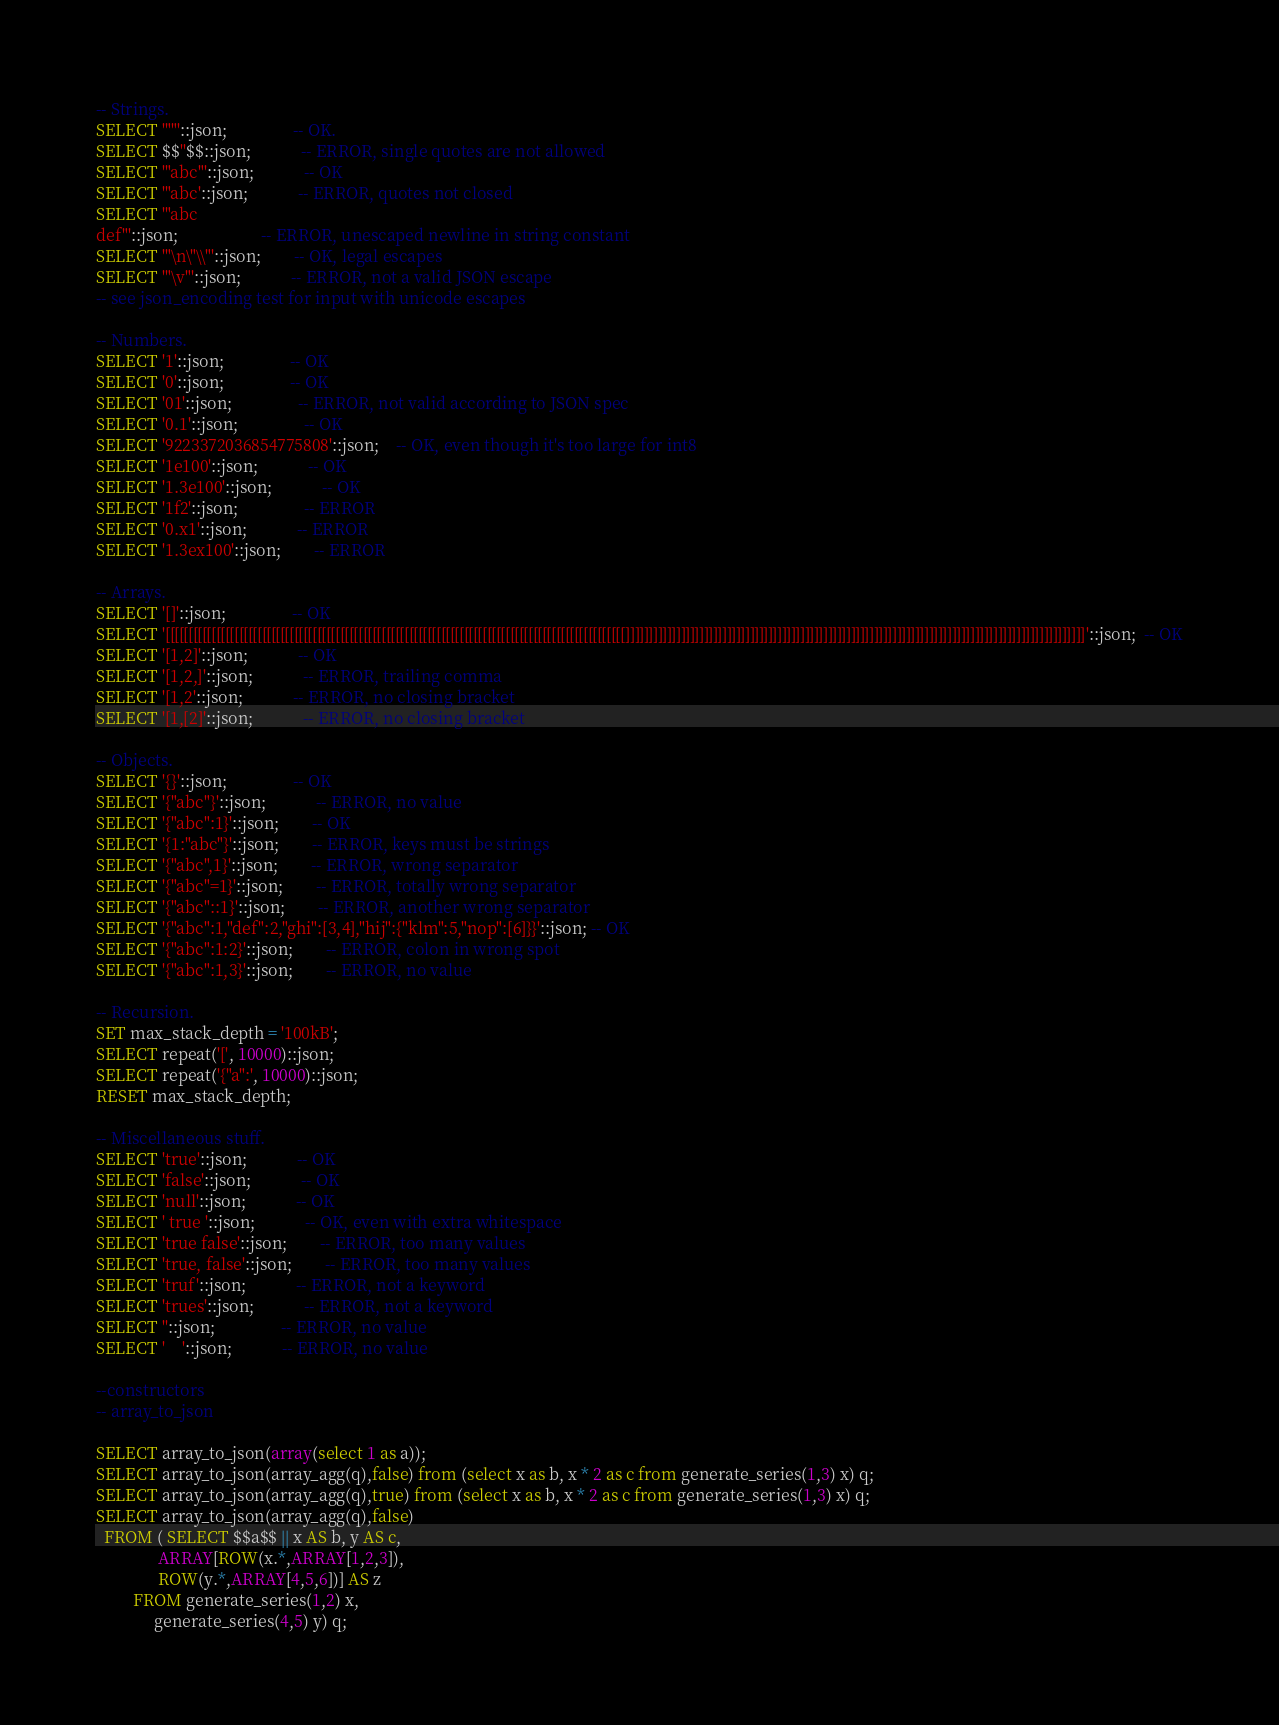Convert code to text. <code><loc_0><loc_0><loc_500><loc_500><_SQL_>-- Strings.
SELECT '""'::json;				-- OK.
SELECT $$''$$::json;			-- ERROR, single quotes are not allowed
SELECT '"abc"'::json;			-- OK
SELECT '"abc'::json;			-- ERROR, quotes not closed
SELECT '"abc
def"'::json;					-- ERROR, unescaped newline in string constant
SELECT '"\n\"\\"'::json;		-- OK, legal escapes
SELECT '"\v"'::json;			-- ERROR, not a valid JSON escape
-- see json_encoding test for input with unicode escapes

-- Numbers.
SELECT '1'::json;				-- OK
SELECT '0'::json;				-- OK
SELECT '01'::json;				-- ERROR, not valid according to JSON spec
SELECT '0.1'::json;				-- OK
SELECT '9223372036854775808'::json;	-- OK, even though it's too large for int8
SELECT '1e100'::json;			-- OK
SELECT '1.3e100'::json;			-- OK
SELECT '1f2'::json;				-- ERROR
SELECT '0.x1'::json;			-- ERROR
SELECT '1.3ex100'::json;		-- ERROR

-- Arrays.
SELECT '[]'::json;				-- OK
SELECT '[[[[[[[[[[[[[[[[[[[[[[[[[[[[[[[[[[[[[[[[[[[[[[[[[[[[[[[[[[[[[[[[[[[[[[[[[[[[[[[[[[[[[[[[[[[[[[[[[[[[]]]]]]]]]]]]]]]]]]]]]]]]]]]]]]]]]]]]]]]]]]]]]]]]]]]]]]]]]]]]]]]]]]]]]]]]]]]]]]]]]]]]]]]]]]]]]]]]]]]]'::json;  -- OK
SELECT '[1,2]'::json;			-- OK
SELECT '[1,2,]'::json;			-- ERROR, trailing comma
SELECT '[1,2'::json;			-- ERROR, no closing bracket
SELECT '[1,[2]'::json;			-- ERROR, no closing bracket

-- Objects.
SELECT '{}'::json;				-- OK
SELECT '{"abc"}'::json;			-- ERROR, no value
SELECT '{"abc":1}'::json;		-- OK
SELECT '{1:"abc"}'::json;		-- ERROR, keys must be strings
SELECT '{"abc",1}'::json;		-- ERROR, wrong separator
SELECT '{"abc"=1}'::json;		-- ERROR, totally wrong separator
SELECT '{"abc"::1}'::json;		-- ERROR, another wrong separator
SELECT '{"abc":1,"def":2,"ghi":[3,4],"hij":{"klm":5,"nop":[6]}}'::json; -- OK
SELECT '{"abc":1:2}'::json;		-- ERROR, colon in wrong spot
SELECT '{"abc":1,3}'::json;		-- ERROR, no value

-- Recursion.
SET max_stack_depth = '100kB';
SELECT repeat('[', 10000)::json;
SELECT repeat('{"a":', 10000)::json;
RESET max_stack_depth;

-- Miscellaneous stuff.
SELECT 'true'::json;			-- OK
SELECT 'false'::json;			-- OK
SELECT 'null'::json;			-- OK
SELECT ' true '::json;			-- OK, even with extra whitespace
SELECT 'true false'::json;		-- ERROR, too many values
SELECT 'true, false'::json;		-- ERROR, too many values
SELECT 'truf'::json;			-- ERROR, not a keyword
SELECT 'trues'::json;			-- ERROR, not a keyword
SELECT ''::json;				-- ERROR, no value
SELECT '    '::json;			-- ERROR, no value

--constructors
-- array_to_json

SELECT array_to_json(array(select 1 as a));
SELECT array_to_json(array_agg(q),false) from (select x as b, x * 2 as c from generate_series(1,3) x) q;
SELECT array_to_json(array_agg(q),true) from (select x as b, x * 2 as c from generate_series(1,3) x) q;
SELECT array_to_json(array_agg(q),false)
  FROM ( SELECT $$a$$ || x AS b, y AS c,
               ARRAY[ROW(x.*,ARRAY[1,2,3]),
               ROW(y.*,ARRAY[4,5,6])] AS z
         FROM generate_series(1,2) x,
              generate_series(4,5) y) q;</code> 